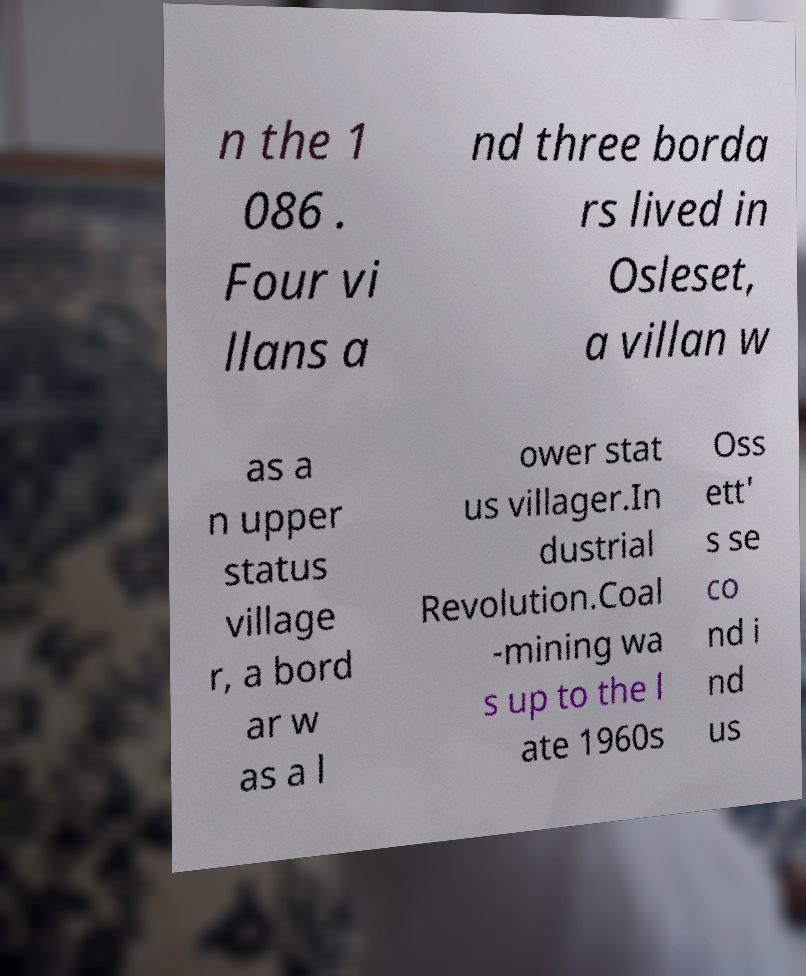There's text embedded in this image that I need extracted. Can you transcribe it verbatim? n the 1 086 . Four vi llans a nd three borda rs lived in Osleset, a villan w as a n upper status village r, a bord ar w as a l ower stat us villager.In dustrial Revolution.Coal -mining wa s up to the l ate 1960s Oss ett' s se co nd i nd us 